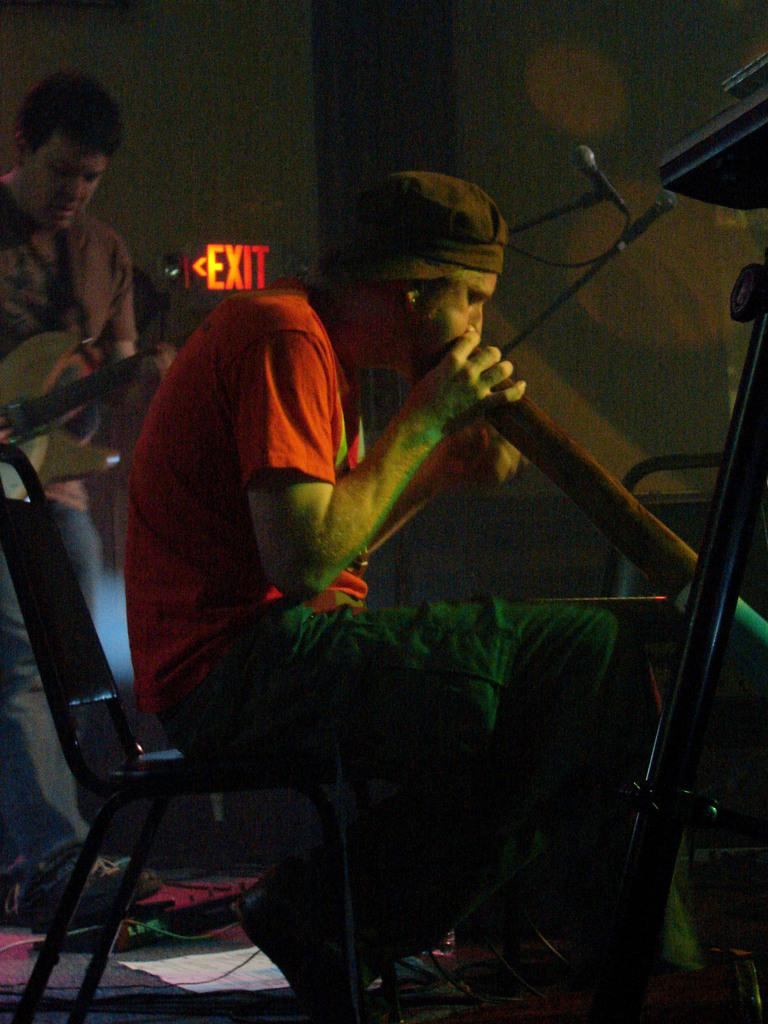What is the man in the image doing while seated on a chair? The man is playing an instrument. Can you describe the other person in the image? There is another man playing a guitar in the image. How is the guitar player positioned? The guitar player is positioned on his back. What type of soda is the man drinking while playing the instrument? There is no soda present in the image; the man is playing an instrument while seated on a chair. 